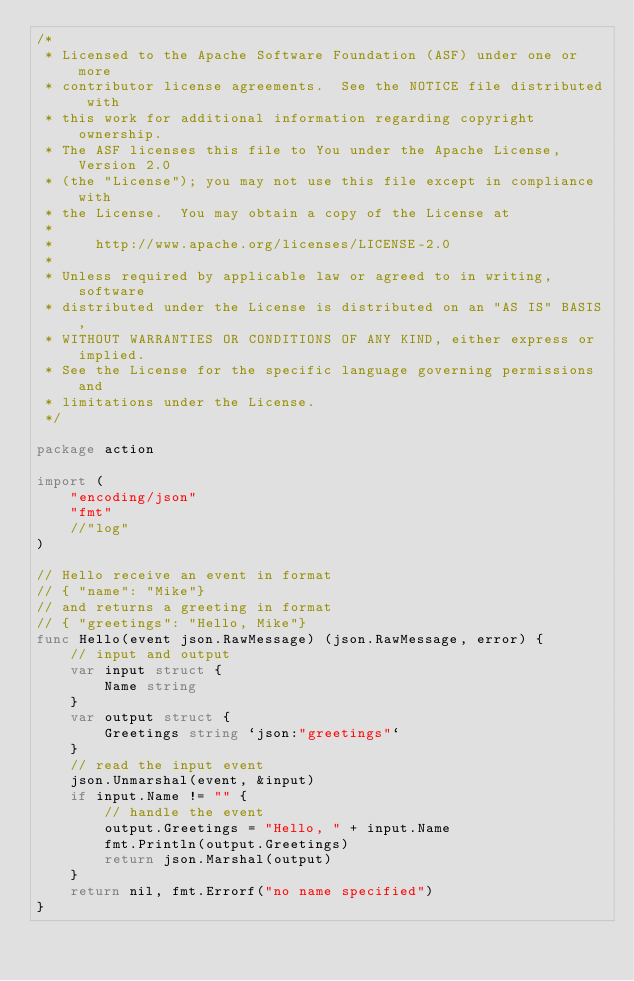Convert code to text. <code><loc_0><loc_0><loc_500><loc_500><_Go_>/*
 * Licensed to the Apache Software Foundation (ASF) under one or more
 * contributor license agreements.  See the NOTICE file distributed with
 * this work for additional information regarding copyright ownership.
 * The ASF licenses this file to You under the Apache License, Version 2.0
 * (the "License"); you may not use this file except in compliance with
 * the License.  You may obtain a copy of the License at
 *
 *     http://www.apache.org/licenses/LICENSE-2.0
 *
 * Unless required by applicable law or agreed to in writing, software
 * distributed under the License is distributed on an "AS IS" BASIS,
 * WITHOUT WARRANTIES OR CONDITIONS OF ANY KIND, either express or implied.
 * See the License for the specific language governing permissions and
 * limitations under the License.
 */

package action

import (
	"encoding/json"
	"fmt"
	//"log"
)

// Hello receive an event in format
// { "name": "Mike"}
// and returns a greeting in format
// { "greetings": "Hello, Mike"}
func Hello(event json.RawMessage) (json.RawMessage, error) {
	// input and output
	var input struct {
		Name string
	}
	var output struct {
		Greetings string `json:"greetings"`
	}
	// read the input event
	json.Unmarshal(event, &input)
	if input.Name != "" {
		// handle the event
		output.Greetings = "Hello, " + input.Name
		fmt.Println(output.Greetings)
		return json.Marshal(output)
	}
	return nil, fmt.Errorf("no name specified")
}
</code> 